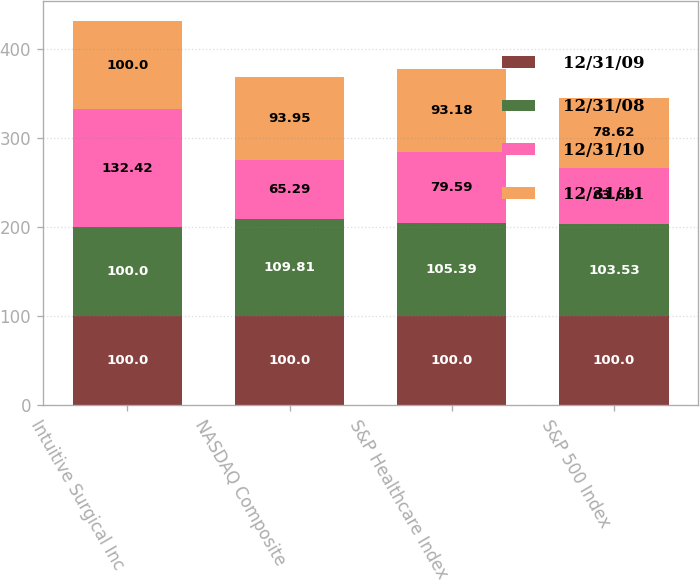Convert chart. <chart><loc_0><loc_0><loc_500><loc_500><stacked_bar_chart><ecel><fcel>Intuitive Surgical Inc<fcel>NASDAQ Composite<fcel>S&P Healthcare Index<fcel>S&P 500 Index<nl><fcel>12/31/09<fcel>100<fcel>100<fcel>100<fcel>100<nl><fcel>12/31/08<fcel>100<fcel>109.81<fcel>105.39<fcel>103.53<nl><fcel>12/31/10<fcel>132.42<fcel>65.29<fcel>79.59<fcel>63.69<nl><fcel>12/31/11<fcel>100<fcel>93.95<fcel>93.18<fcel>78.62<nl></chart> 